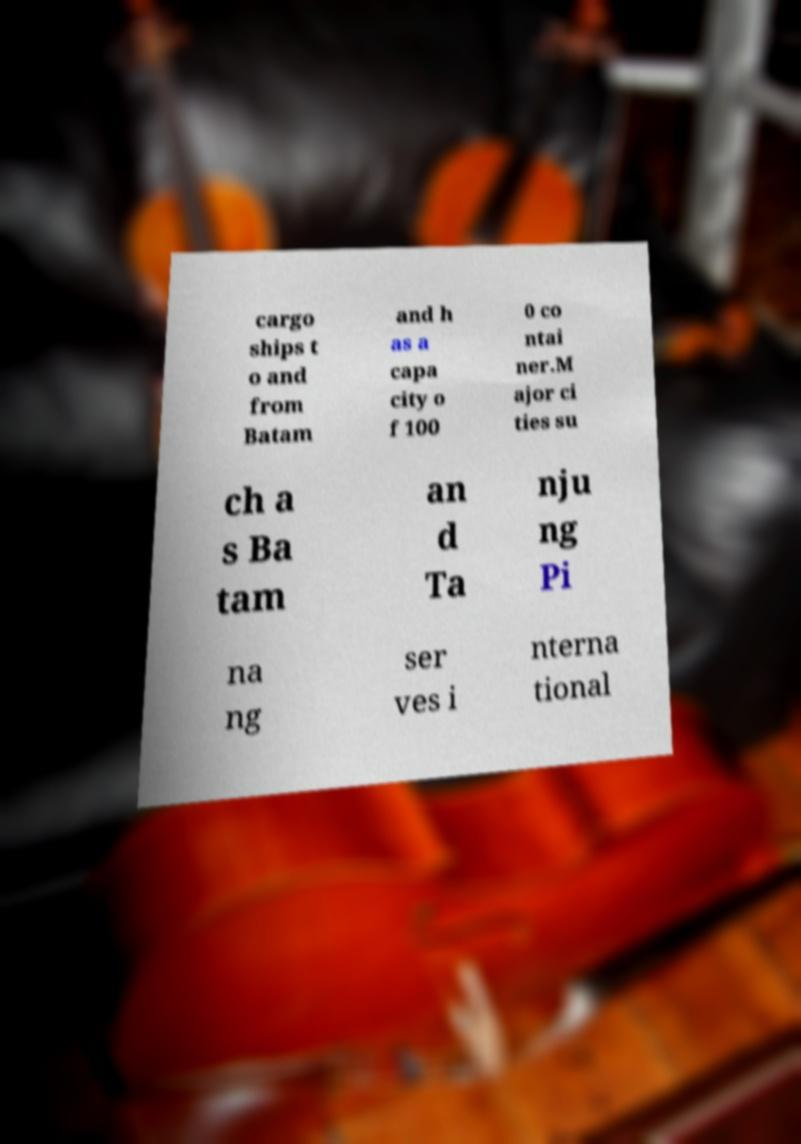There's text embedded in this image that I need extracted. Can you transcribe it verbatim? cargo ships t o and from Batam and h as a capa city o f 100 0 co ntai ner.M ajor ci ties su ch a s Ba tam an d Ta nju ng Pi na ng ser ves i nterna tional 